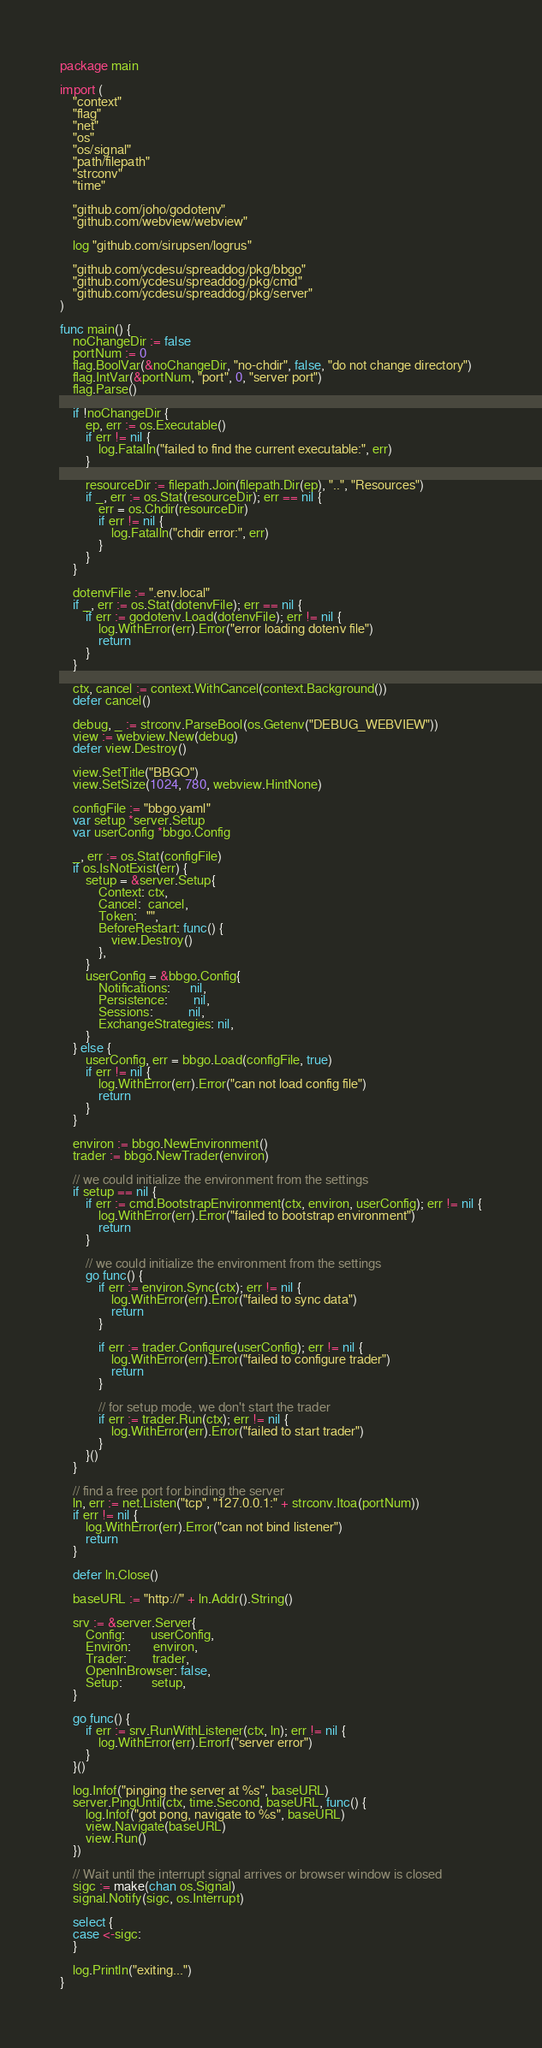Convert code to text. <code><loc_0><loc_0><loc_500><loc_500><_Go_>package main

import (
	"context"
	"flag"
	"net"
	"os"
	"os/signal"
	"path/filepath"
	"strconv"
	"time"

	"github.com/joho/godotenv"
	"github.com/webview/webview"

	log "github.com/sirupsen/logrus"

	"github.com/ycdesu/spreaddog/pkg/bbgo"
	"github.com/ycdesu/spreaddog/pkg/cmd"
	"github.com/ycdesu/spreaddog/pkg/server"
)

func main() {
	noChangeDir := false
	portNum := 0
	flag.BoolVar(&noChangeDir, "no-chdir", false, "do not change directory")
	flag.IntVar(&portNum, "port", 0, "server port")
	flag.Parse()

	if !noChangeDir {
		ep, err := os.Executable()
		if err != nil {
			log.Fatalln("failed to find the current executable:", err)
		}

		resourceDir := filepath.Join(filepath.Dir(ep), "..", "Resources")
		if _, err := os.Stat(resourceDir); err == nil {
			err = os.Chdir(resourceDir)
			if err != nil {
				log.Fatalln("chdir error:", err)
			}
		}
	}

	dotenvFile := ".env.local"
	if _, err := os.Stat(dotenvFile); err == nil {
		if err := godotenv.Load(dotenvFile); err != nil {
			log.WithError(err).Error("error loading dotenv file")
			return
		}
	}

	ctx, cancel := context.WithCancel(context.Background())
	defer cancel()

	debug, _ := strconv.ParseBool(os.Getenv("DEBUG_WEBVIEW"))
	view := webview.New(debug)
	defer view.Destroy()

	view.SetTitle("BBGO")
	view.SetSize(1024, 780, webview.HintNone)

	configFile := "bbgo.yaml"
	var setup *server.Setup
	var userConfig *bbgo.Config

	_, err := os.Stat(configFile)
	if os.IsNotExist(err) {
		setup = &server.Setup{
			Context: ctx,
			Cancel:  cancel,
			Token:   "",
			BeforeRestart: func() {
				view.Destroy()
			},
		}
		userConfig = &bbgo.Config{
			Notifications:      nil,
			Persistence:        nil,
			Sessions:           nil,
			ExchangeStrategies: nil,
		}
	} else {
		userConfig, err = bbgo.Load(configFile, true)
		if err != nil {
			log.WithError(err).Error("can not load config file")
			return
		}
	}

	environ := bbgo.NewEnvironment()
	trader := bbgo.NewTrader(environ)

	// we could initialize the environment from the settings
	if setup == nil {
		if err := cmd.BootstrapEnvironment(ctx, environ, userConfig); err != nil {
			log.WithError(err).Error("failed to bootstrap environment")
			return
		}

		// we could initialize the environment from the settings
		go func() {
			if err := environ.Sync(ctx); err != nil {
				log.WithError(err).Error("failed to sync data")
				return
			}

			if err := trader.Configure(userConfig); err != nil {
				log.WithError(err).Error("failed to configure trader")
				return
			}

			// for setup mode, we don't start the trader
			if err := trader.Run(ctx); err != nil {
				log.WithError(err).Error("failed to start trader")
			}
		}()
	}

	// find a free port for binding the server
	ln, err := net.Listen("tcp", "127.0.0.1:" + strconv.Itoa(portNum))
	if err != nil {
		log.WithError(err).Error("can not bind listener")
		return
	}

	defer ln.Close()

	baseURL := "http://" + ln.Addr().String()

	srv := &server.Server{
		Config:        userConfig,
		Environ:       environ,
		Trader:        trader,
		OpenInBrowser: false,
		Setup:         setup,
	}

	go func() {
		if err := srv.RunWithListener(ctx, ln); err != nil {
			log.WithError(err).Errorf("server error")
		}
	}()

	log.Infof("pinging the server at %s", baseURL)
	server.PingUntil(ctx, time.Second, baseURL, func() {
		log.Infof("got pong, navigate to %s", baseURL)
		view.Navigate(baseURL)
		view.Run()
	})

	// Wait until the interrupt signal arrives or browser window is closed
	sigc := make(chan os.Signal)
	signal.Notify(sigc, os.Interrupt)

	select {
	case <-sigc:
	}

	log.Println("exiting...")
}
</code> 